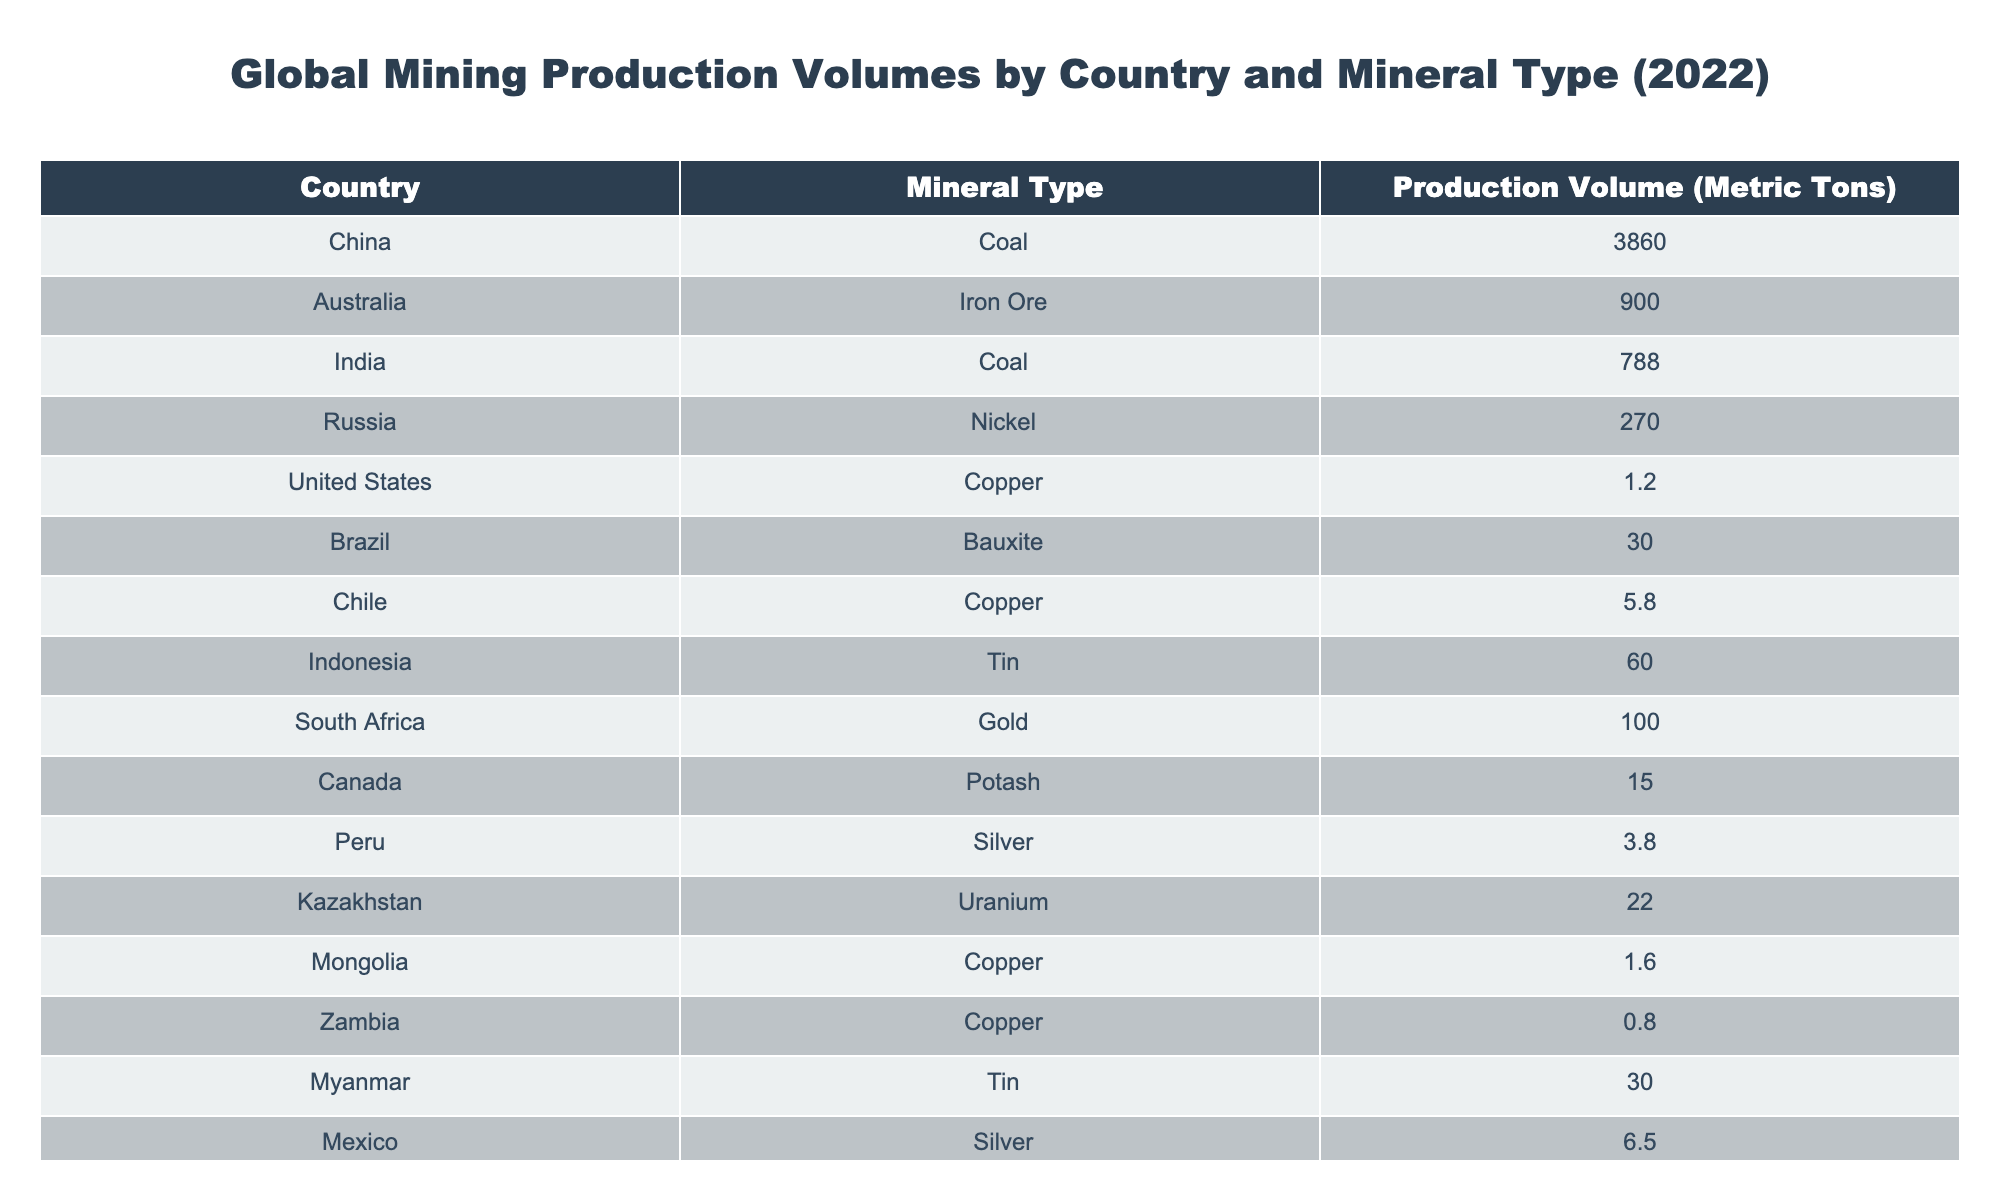What country produced the most coal in 2022? According to the table, China produced the largest amount of coal, totaling 3860 metric tons.
Answer: China How much copper was produced in Chile compared to the United States? Chile produced 5.8 metric tons of copper while the United States produced 1.2 metric tons. Comparing them, Chile produced 5.8 - 1.2 = 4.6 metric tons more than the United States.
Answer: 4.6 metric tons Is India the largest producer of coal? No, India produced 788 metric tons of coal, which is significantly less than China's production of 3860 metric tons.
Answer: No What is the total production of silver from Peru and Mexico combined? Peru produced 3.8 metric tons of silver and Mexico produced 6.5 metric tons. The combined production is 3.8 + 6.5 = 10.3 metric tons.
Answer: 10.3 metric tons Which mineral type had the least production volume in the table? The mineral types with the least production volume are Copper from the United States (1.2 metric tons) and Copper from Zambia (0.8 metric tons). The least among these is Zambia with 0.8 metric tons.
Answer: Copper from Zambia (0.8 metric tons) How many countries in the table produced tin? The table lists Indonesia and Myanmar as the two countries that produced tin, totaling two entries for the mineral type.
Answer: 2 countries What is the total production volume of iron ore and bauxite? Australia produced 900 metric tons of iron ore and Brazil produced 30 metric tons of bauxite. The total production is 900 + 30 = 930 metric tons.
Answer: 930 metric tons Was the production volume of gold higher than that of potash? South Africa produced 100 metric tons of gold, while Canada produced 15 metric tons of potash. Since 100 is greater than 15, the statement is true.
Answer: Yes How does the copper production in Zambia compare to that of Mongolia? Zambia produced 0.8 metric tons of copper, while Mongolia produced 1.6 metric tons. Since 1.6 is greater than 0.8, Mongolia produced more copper than Zambia by 1.6 - 0.8 = 0.8 metric tons.
Answer: Mongolia produced 0.8 metric tons more 